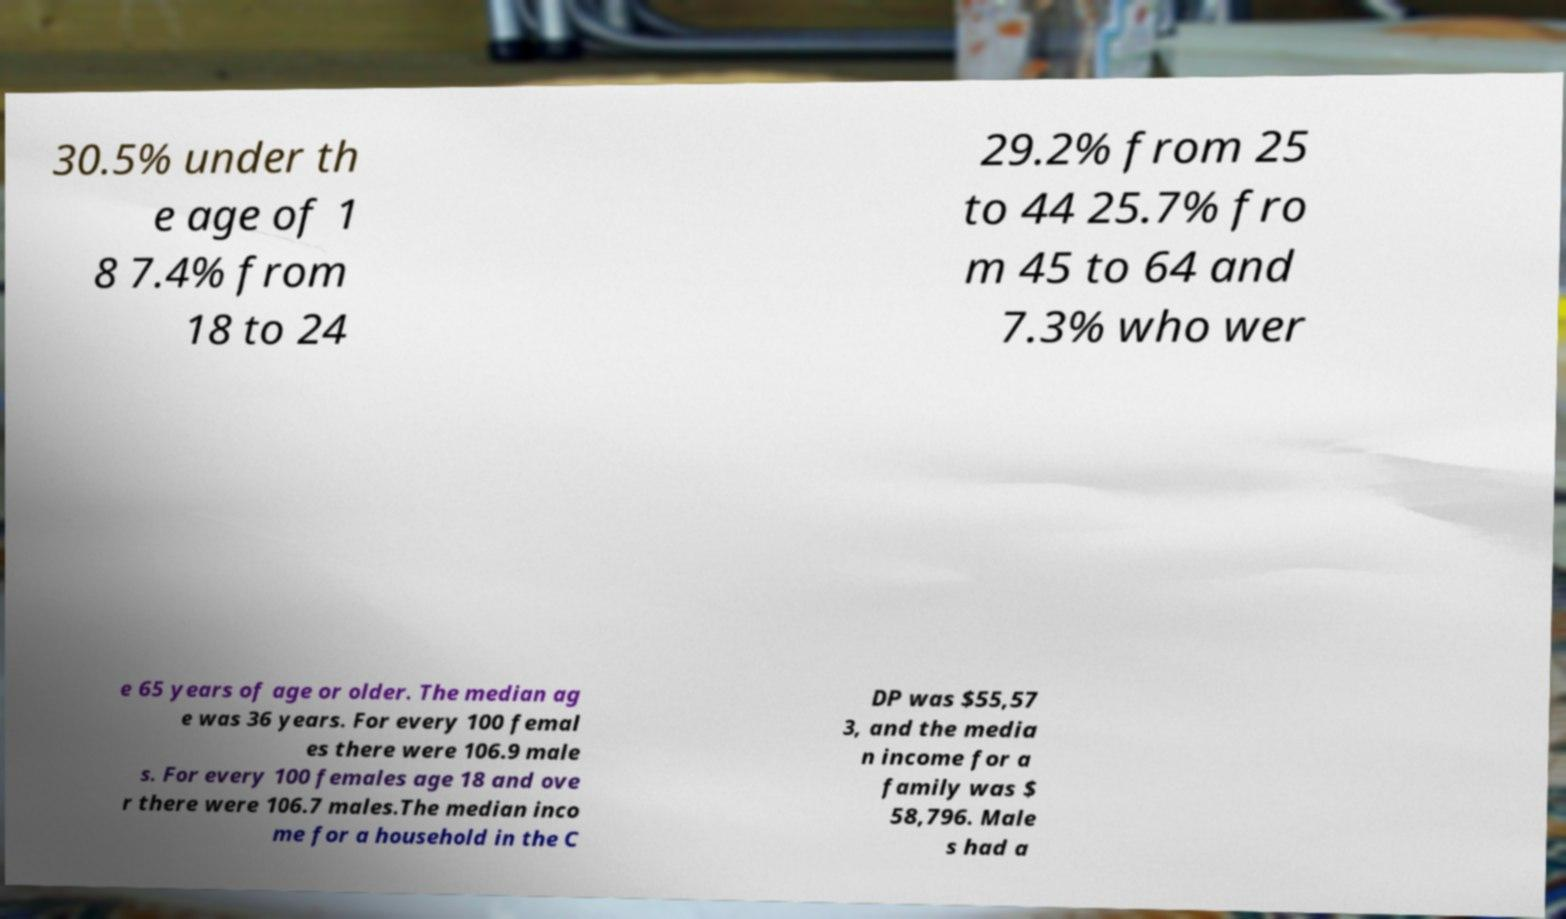For documentation purposes, I need the text within this image transcribed. Could you provide that? 30.5% under th e age of 1 8 7.4% from 18 to 24 29.2% from 25 to 44 25.7% fro m 45 to 64 and 7.3% who wer e 65 years of age or older. The median ag e was 36 years. For every 100 femal es there were 106.9 male s. For every 100 females age 18 and ove r there were 106.7 males.The median inco me for a household in the C DP was $55,57 3, and the media n income for a family was $ 58,796. Male s had a 